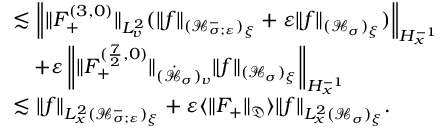<formula> <loc_0><loc_0><loc_500><loc_500>\begin{array} { r l } & { \lesssim \left \| \| F _ { + } ^ { ( 3 , 0 ) } \| _ { L _ { v } ^ { 2 } } ( \| f \| _ { ( \mathcal { H } _ { \sigma ; \varepsilon } ^ { - } ) _ { \xi } } + \varepsilon \| f \| _ { ( \mathcal { H } _ { \sigma } ) _ { \xi } } ) \right \| _ { H _ { x } ^ { - 1 } } } \\ & { \quad + \varepsilon \left \| \| F _ { + } ^ { ( \frac { 7 } { 2 } , 0 ) } \| _ { ( \dot { \mathcal { H } } _ { \sigma } ) _ { v } } \| f \| _ { ( \mathcal { H } _ { \sigma } ) _ { \xi } } \right \| _ { H _ { x } ^ { - 1 } } } \\ & { \lesssim \| f \| _ { L _ { x } ^ { 2 } ( \mathcal { H } _ { \sigma ; \varepsilon } ^ { - } ) _ { \xi } } + \varepsilon \langle \| F _ { + } \| _ { \mathfrak D } \rangle \| f \| _ { L _ { x } ^ { 2 } ( \mathcal { H } _ { \sigma } ) _ { \xi } } . } \end{array}</formula> 